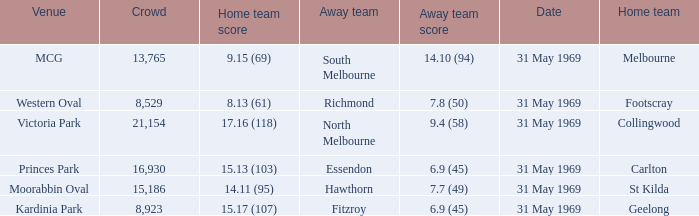Who was the home team in the game where North Melbourne was the away team? 17.16 (118). Could you parse the entire table? {'header': ['Venue', 'Crowd', 'Home team score', 'Away team', 'Away team score', 'Date', 'Home team'], 'rows': [['MCG', '13,765', '9.15 (69)', 'South Melbourne', '14.10 (94)', '31 May 1969', 'Melbourne'], ['Western Oval', '8,529', '8.13 (61)', 'Richmond', '7.8 (50)', '31 May 1969', 'Footscray'], ['Victoria Park', '21,154', '17.16 (118)', 'North Melbourne', '9.4 (58)', '31 May 1969', 'Collingwood'], ['Princes Park', '16,930', '15.13 (103)', 'Essendon', '6.9 (45)', '31 May 1969', 'Carlton'], ['Moorabbin Oval', '15,186', '14.11 (95)', 'Hawthorn', '7.7 (49)', '31 May 1969', 'St Kilda'], ['Kardinia Park', '8,923', '15.17 (107)', 'Fitzroy', '6.9 (45)', '31 May 1969', 'Geelong']]} 